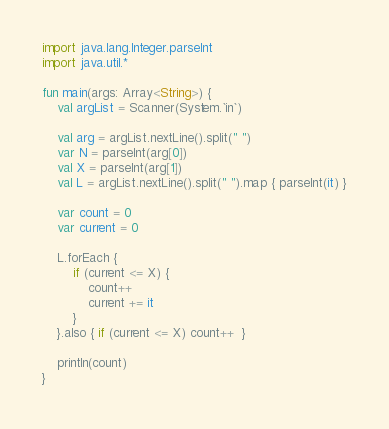Convert code to text. <code><loc_0><loc_0><loc_500><loc_500><_Kotlin_>import java.lang.Integer.parseInt
import java.util.*

fun main(args: Array<String>) {
    val argList = Scanner(System.`in`)

    val arg = argList.nextLine().split(" ")
    var N = parseInt(arg[0])
    val X = parseInt(arg[1])
    val L = argList.nextLine().split(" ").map { parseInt(it) }

    var count = 0
    var current = 0

    L.forEach {
        if (current <= X) {
            count++
            current += it
        }
    }.also { if (current <= X) count++  }

    println(count)
}
</code> 